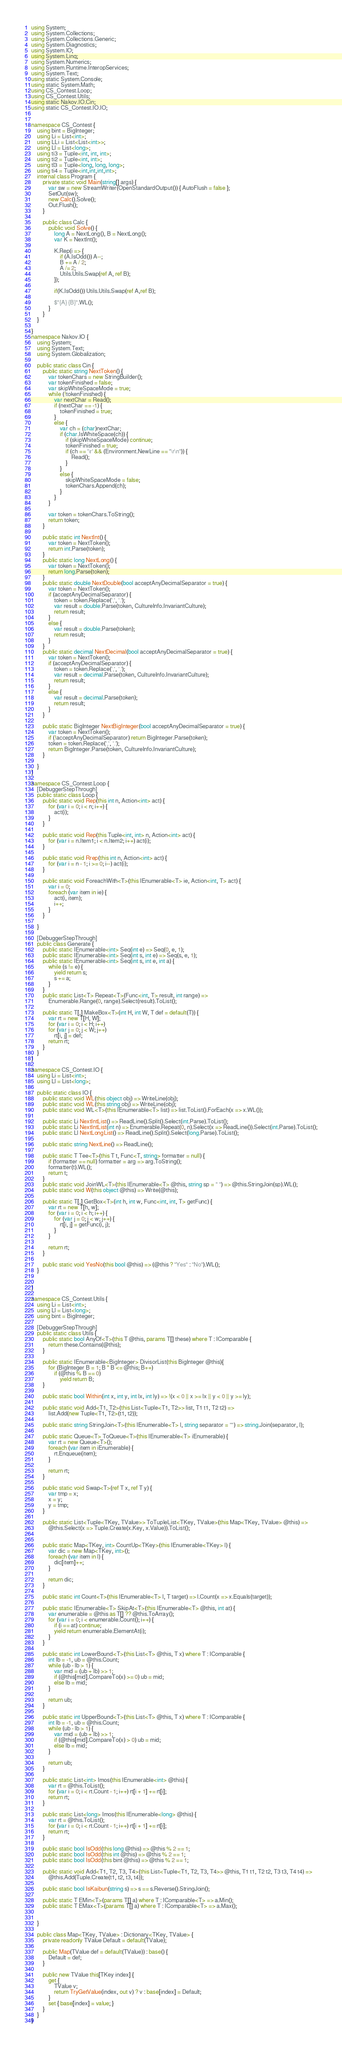<code> <loc_0><loc_0><loc_500><loc_500><_C#_>using System;
using System.Collections;
using System.Collections.Generic;
using System.Diagnostics;
using System.IO;
using System.Linq;
using System.Numerics;
using System.Runtime.InteropServices;
using System.Text;
using static System.Console;
using static System.Math;
using CS_Contest.Loop;
using CS_Contest.Utils;
using static Nakov.IO.Cin;
using static CS_Contest.IO.IO;


namespace CS_Contest {
    using bint = BigInteger;
    using Li = List<int>;
    using LLi = List<List<int>>;
    using Ll = List<long>;
    using ti3 = Tuple<int, int, int>;
    using ti2 = Tuple<int, int>;
    using tl3 = Tuple<long, long, long>;
    using ti4 = Tuple<int,int,int,int>;
    internal class Program {
        private static void Main(string[] args) {
            var sw = new StreamWriter(OpenStandardOutput()) { AutoFlush = false };
            SetOut(sw);
            new Calc().Solve();
            Out.Flush();
        }

        public class Calc {
            public void Solve() {
	            long A = NextLong(), B = NextLong();
	            var K = NextInt();
				
				K.Rep(i => {
					if (A.IsOdd()) A--;
					B += A / 2;
					A /= 2;
					Utils.Utils.Swap(ref A, ref B);
				});

				if(K.IsOdd()) Utils.Utils.Swap(ref A,ref B);

				$"{A} {B}".WL();
            }
        }
    }
    
}
namespace Nakov.IO {
    using System;
    using System.Text;
    using System.Globalization;

    public static class Cin {
        public static string NextToken() {
            var tokenChars = new StringBuilder();
            var tokenFinished = false;
            var skipWhiteSpaceMode = true;
            while (!tokenFinished) {
                var nextChar = Read();
                if (nextChar == -1) {
                    tokenFinished = true;
                }
                else {
                    var ch = (char)nextChar;
                    if (char.IsWhiteSpace(ch)) {
                        if (skipWhiteSpaceMode) continue;
                        tokenFinished = true;
                        if (ch == '\r' && (Environment.NewLine == "\r\n")) {
                            Read();
                        }
                    }
                    else {
                        skipWhiteSpaceMode = false;
                        tokenChars.Append(ch);
                    }
                }
            }

            var token = tokenChars.ToString();
            return token;
        }

        public static int NextInt() {
            var token = NextToken();
            return int.Parse(token);
        }
        public static long NextLong() {
            var token = NextToken();
            return long.Parse(token);
        }
        public static double NextDouble(bool acceptAnyDecimalSeparator = true) {
            var token = NextToken();
            if (acceptAnyDecimalSeparator) {
                token = token.Replace(',', '.');
                var result = double.Parse(token, CultureInfo.InvariantCulture);
                return result;
            }
            else {
                var result = double.Parse(token);
                return result;
            }
        }
        public static decimal NextDecimal(bool acceptAnyDecimalSeparator = true) {
            var token = NextToken();
            if (acceptAnyDecimalSeparator) {
                token = token.Replace(',', '.');
                var result = decimal.Parse(token, CultureInfo.InvariantCulture);
                return result;
            }
            else {
                var result = decimal.Parse(token);
                return result;
            }
        }

        public static BigInteger NextBigInteger(bool acceptAnyDecimalSeparator = true) {
            var token = NextToken();
            if (!acceptAnyDecimalSeparator) return BigInteger.Parse(token);
            token = token.Replace(',', '.');
            return BigInteger.Parse(token, CultureInfo.InvariantCulture);
        }

    }
}

namespace CS_Contest.Loop {
    [DebuggerStepThrough]
    public static class Loop {
        public static void Rep(this int n, Action<int> act) {
            for (var i = 0; i < n; i++) {
                act(i);
            }
        }

        public static void Rep(this Tuple<int, int> n, Action<int> act) {
            for (var i = n.Item1; i < n.Item2; i++) act(i);
        }

        public static void Rrep(this int n, Action<int> act) {
            for (var i = n - 1; i >= 0; i--) act(i);
        }

        public static void ForeachWith<T>(this IEnumerable<T> ie, Action<int, T> act) {
            var i = 0;
            foreach (var item in ie) {
                act(i, item);
                i++;
            }
        }

    }

    [DebuggerStepThrough]
    public class Generate {
        public static IEnumerable<int> Seq(int e) => Seq(0, e, 1);
        public static IEnumerable<int> Seq(int s, int e) => Seq(s, e, 1);
        public static IEnumerable<int> Seq(int s, int e, int a) {
            while (s != e) {
                yield return s;
                s += a;
            }
        }
        public static List<T> Repeat<T>(Func<int, T> result, int range) =>
            Enumerable.Range(0, range).Select(result).ToList();

        public static T[,] MakeBox<T>(int H, int W, T def = default(T)) {
            var rt = new T[H, W];
            for (var i = 0; i < H; i++)
            for (var j = 0; j < W; j++)
                rt[i, j] = def;
            return rt;
        }
    }
}

namespace CS_Contest.IO {
    using Li = List<int>;
    using Ll = List<long>;

    public static class IO {
        public static void WL(this object obj) => WriteLine(obj);
        public static void WL(this string obj) => WriteLine(obj);
        public static void WL<T>(this IEnumerable<T> list) => list.ToList().ForEach(x => x.WL());

        public static Li NextIntList() => ReadLine().Split().Select(int.Parse).ToList();
        public static Li NextIntList(int n) => Enumerable.Repeat(0, n).Select(x => ReadLine()).Select(int.Parse).ToList();
        public static Ll NextLongList() => ReadLine().Split().Select(long.Parse).ToList();

        public static string NextLine() => ReadLine();

        public static T Tee<T>(this T t, Func<T, string> formatter = null) {
            if (formatter == null) formatter = arg => arg.ToString();
            formatter(t).WL();
            return t;
        }
        public static void JoinWL<T>(this IEnumerable<T> @this, string sp = " ") => @this.StringJoin(sp).WL();
        public static void W(this object @this) => Write(@this);

        public static T[,] GetBox<T>(int h, int w, Func<int, int, T> getFunc) {
            var rt = new T[h, w];
            for (var i = 0; i < h; i++) {
                for (var j = 0; j < w; j++) {
                    rt[i, j] = getFunc(i, j);
                }
            }

            return rt;
        }

        public static void YesNo(this bool @this) => (@this ? "Yes" : "No").WL();
    }


}

namespace CS_Contest.Utils {
    using Li = List<int>;
    using Ll = List<long>;
    using bint = BigInteger;

    [DebuggerStepThrough]
    public static class Utils {
        public static bool AnyOf<T>(this T @this, params T[] these) where T : IComparable {
            return these.Contains(@this);
        }

        public static IEnumerable<BigInteger> DivisorList(this BigInteger @this){
            for (BigInteger B = 1; B * B <= @this; B++)
                if (@this % B == 0)
                    yield return B;
        }

        public static bool Within(int x, int y, int lx, int ly) => !(x < 0 || x >= lx || y < 0 || y >= ly);

        public static void Add<T1, T2>(this List<Tuple<T1, T2>> list, T1 t1, T2 t2) =>
            list.Add(new Tuple<T1, T2>(t1, t2));

        public static string StringJoin<T>(this IEnumerable<T> l, string separator = "") => string.Join(separator, l);

        public static Queue<T> ToQueue<T>(this IEnumerable<T> iEnumerable) {
            var rt = new Queue<T>();
            foreach (var item in iEnumerable) {
                rt.Enqueue(item);
            }

            return rt;
        }

        public static void Swap<T>(ref T x, ref T y) {
            var tmp = x;
            x = y;
            y = tmp;
        }

        public static List<Tuple<TKey, TValue>> ToTupleList<TKey, TValue>(this Map<TKey, TValue> @this) =>
            @this.Select(x => Tuple.Create(x.Key, x.Value)).ToList();


        public static Map<TKey, int> CountUp<TKey>(this IEnumerable<TKey> l) {
            var dic = new Map<TKey, int>();
            foreach (var item in l) {
                dic[item]++;
            }

            return dic;
        }

        public static int Count<T>(this IEnumerable<T> l, T target) => l.Count(x => x.Equals(target));

        public static IEnumerable<T> SkipAt<T>(this IEnumerable<T> @this, int at) {
            var enumerable = @this as T[] ?? @this.ToArray();
            for (var i = 0; i < enumerable.Count(); i++) {
                if (i == at) continue;
                yield return enumerable.ElementAt(i);
            }
        }

        public static int LowerBound<T>(this List<T> @this, T x) where T : IComparable {
            int lb = -1, ub = @this.Count;
            while (ub - lb > 1) {
                var mid = (ub + lb) >> 1;
                if (@this[mid].CompareTo(x) >= 0) ub = mid;
                else lb = mid;
            }

            return ub;
        }

        public static int UpperBound<T>(this List<T> @this, T x) where T : IComparable {
            int lb = -1, ub = @this.Count;
            while (ub - lb > 1) {
                var mid = (ub + lb) >> 1;
                if (@this[mid].CompareTo(x) > 0) ub = mid;
                else lb = mid;
            }

            return ub;
        }

        public static List<int> Imos(this IEnumerable<int> @this) {
            var rt = @this.ToList();
            for (var i = 0; i < rt.Count - 1; i++) rt[i + 1] += rt[i];
            return rt;
        }

        public static List<long> Imos(this IEnumerable<long> @this) {
            var rt = @this.ToList();
            for (var i = 0; i < rt.Count - 1; i++) rt[i + 1] += rt[i];
            return rt;
        }

        public static bool IsOdd(this long @this) => @this % 2 == 1;
        public static bool IsOdd(this int @this) => @this % 2 == 1;
        public static bool IsOdd(this bint @this) => @this % 2 == 1;

        public static void Add<T1, T2, T3, T4>(this List<Tuple<T1, T2, T3, T4>> @this, T1 t1, T2 t2, T3 t3, T4 t4) =>
            @this.Add(Tuple.Create(t1, t2, t3, t4));

        public static bool IsKaibun(string s) => s == s.Reverse().StringJoin();

        public static T EMin<T>(params T[] a) where T : IComparable<T> => a.Min();
        public static T EMax<T>(params T[] a) where T : IComparable<T> => a.Max();

        
    }

    public class Map<TKey, TValue> : Dictionary<TKey, TValue> {
        private readonly TValue Default = default(TValue);

        public Map(TValue def = default(TValue)) : base() {
            Default = def;
        }

        public new TValue this[TKey index] {
            get {
                TValue v;
                return TryGetValue(index, out v) ? v : base[index] = Default;
            }
            set { base[index] = value; }
        }
    }
}

</code> 